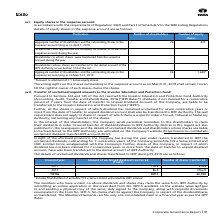According to Tata Consultancy Services's financial document, What does the table show? details of equity shares in the suspense account. The document states: "F of Schedule V to the SEBI Listing Regulations, details of equity shares in the suspense account are as follows:..." Also, How many shareholders approached the Company for transfer of shares from suspense account during the year? According to the financial document, 0. The relevant text states: "res in the suspense account lying as on April 1, 2018 26 820..." Also, How many shareholders have outstanding shares in the suspense account as on March 31, 2019? According to the financial document, 26. The relevant text states: "in the suspense account lying as on April 1, 2018 26 820..." Also, can you calculate: What is the change in the number of equity shares between April 1, 2018 and March 31, 2019? Based on the calculation: 1,640-820, the result is 820. This is based on the information: "he suspense account lying as on March 31, 2019 26 1,640* the suspense account lying as on April 1, 2018 26 820..." The key data points involved are: 1,640. Also, can you calculate: How many equity shares are there to one shareholder as on April 1, 2018? Based on the calculation: 820/26 , the result is 31.54. This is based on the information: "in the suspense account lying as on April 1, 2018 26 820 the suspense account lying as on April 1, 2018 26 820..." The key data points involved are: 26, 820. Also, can you calculate: How many equity shares are there to one shareholder as on March 31, 2019? Based on the calculation: 1,640/26 , the result is 63.08. This is based on the information: "he suspense account lying as on March 31, 2019 26 1,640* in the suspense account lying as on April 1, 2018 26 820..." The key data points involved are: 1,640, 26. 